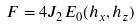Convert formula to latex. <formula><loc_0><loc_0><loc_500><loc_500>F = 4 J _ { 2 } E _ { 0 } ( h _ { x } , h _ { z } )</formula> 